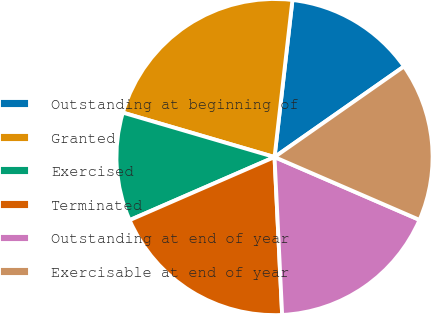<chart> <loc_0><loc_0><loc_500><loc_500><pie_chart><fcel>Outstanding at beginning of<fcel>Granted<fcel>Exercised<fcel>Terminated<fcel>Outstanding at end of year<fcel>Exercisable at end of year<nl><fcel>13.47%<fcel>22.27%<fcel>11.07%<fcel>19.23%<fcel>17.72%<fcel>16.23%<nl></chart> 